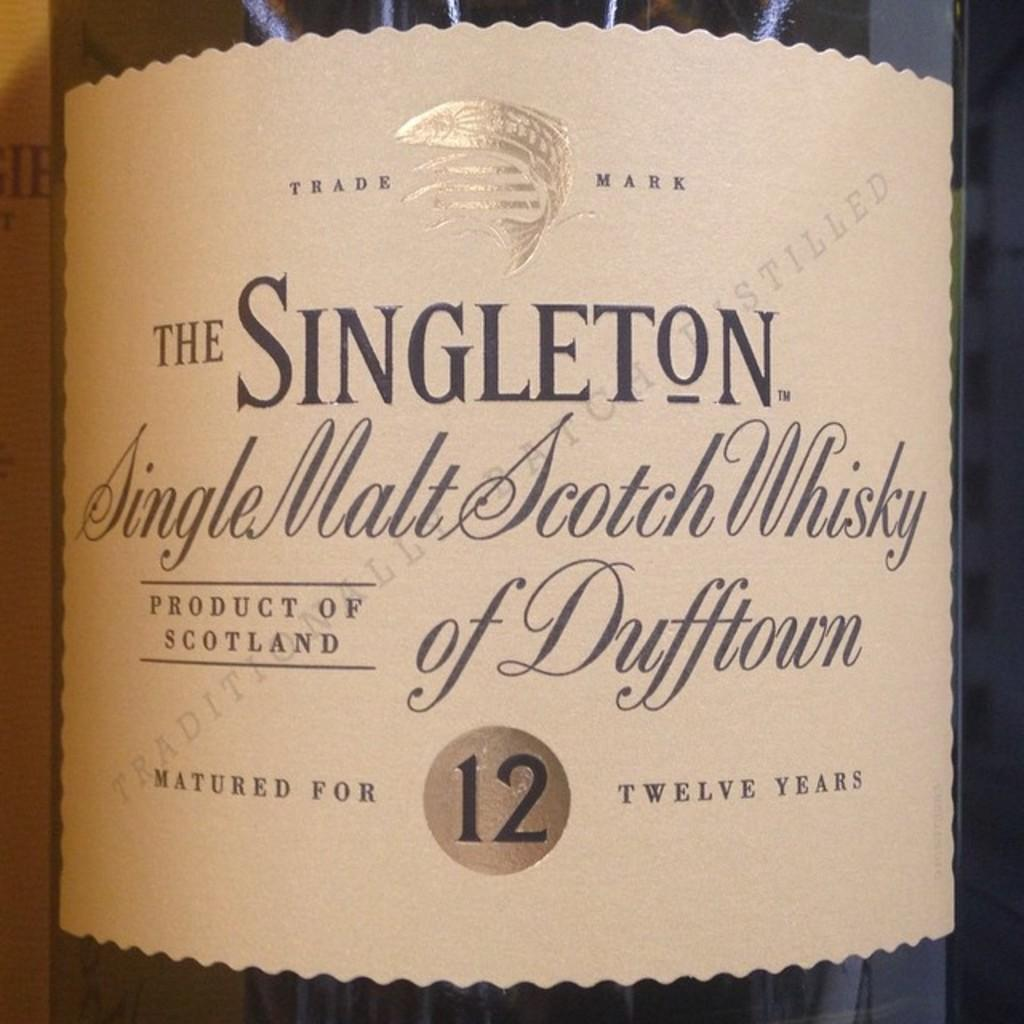<image>
Render a clear and concise summary of the photo. The label for a bottle of single malt scotch whisky of Dufftown. 